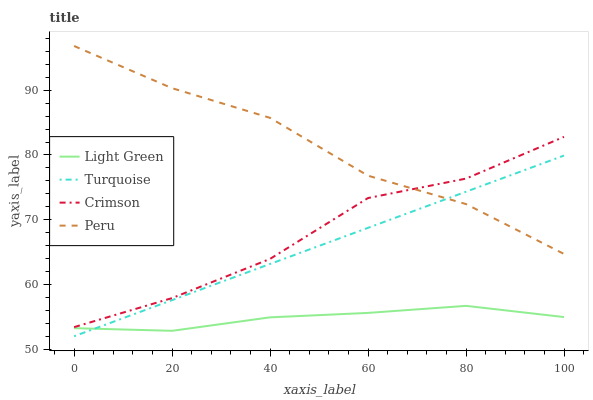Does Light Green have the minimum area under the curve?
Answer yes or no. Yes. Does Peru have the maximum area under the curve?
Answer yes or no. Yes. Does Turquoise have the minimum area under the curve?
Answer yes or no. No. Does Turquoise have the maximum area under the curve?
Answer yes or no. No. Is Turquoise the smoothest?
Answer yes or no. Yes. Is Crimson the roughest?
Answer yes or no. Yes. Is Peru the smoothest?
Answer yes or no. No. Is Peru the roughest?
Answer yes or no. No. Does Turquoise have the lowest value?
Answer yes or no. Yes. Does Peru have the lowest value?
Answer yes or no. No. Does Peru have the highest value?
Answer yes or no. Yes. Does Turquoise have the highest value?
Answer yes or no. No. Is Turquoise less than Crimson?
Answer yes or no. Yes. Is Peru greater than Light Green?
Answer yes or no. Yes. Does Peru intersect Turquoise?
Answer yes or no. Yes. Is Peru less than Turquoise?
Answer yes or no. No. Is Peru greater than Turquoise?
Answer yes or no. No. Does Turquoise intersect Crimson?
Answer yes or no. No. 